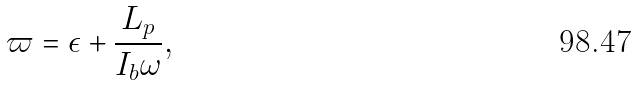Convert formula to latex. <formula><loc_0><loc_0><loc_500><loc_500>\varpi = \epsilon + \frac { L _ { p } } { I _ { b } \omega } ,</formula> 